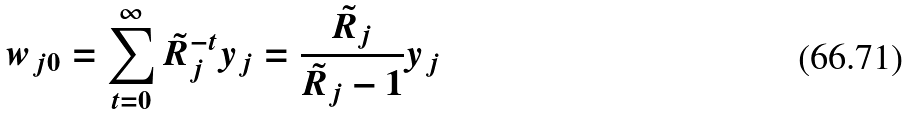Convert formula to latex. <formula><loc_0><loc_0><loc_500><loc_500>w _ { j 0 } = \sum _ { t = 0 } ^ { \infty } \tilde { R } _ { j } ^ { - t } y _ { j } = \frac { \tilde { R } _ { j } } { \tilde { R } _ { j } - 1 } y _ { j }</formula> 